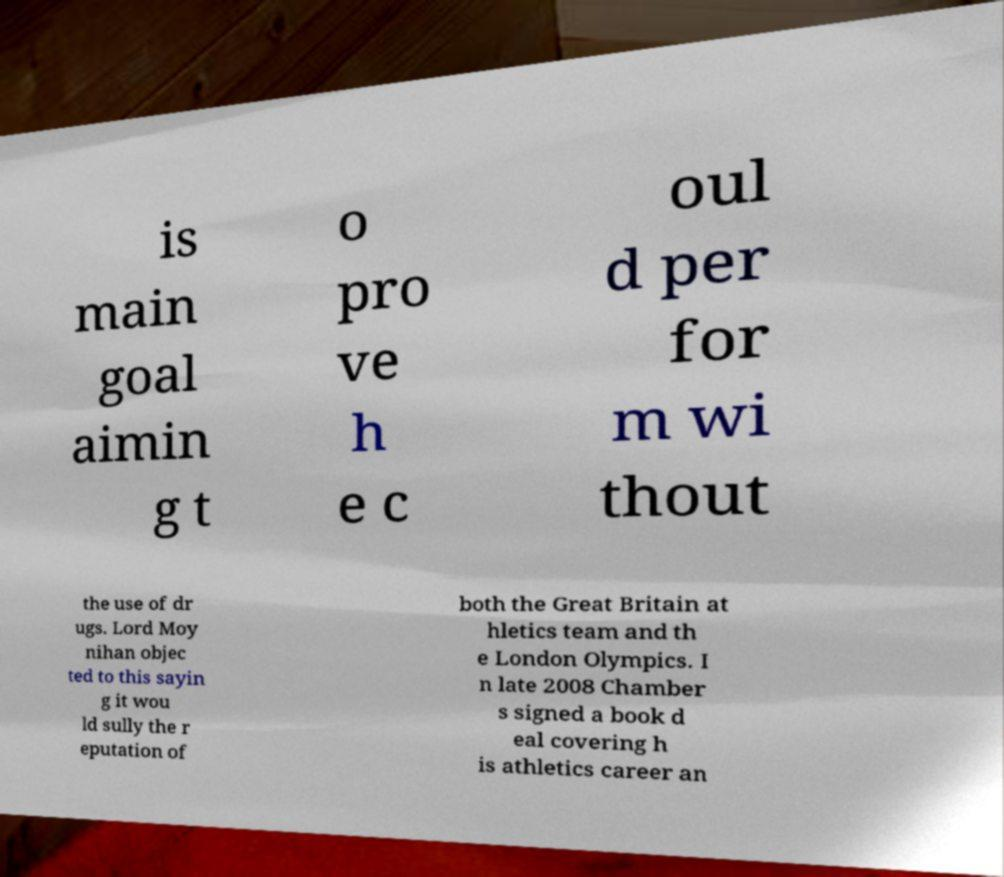For documentation purposes, I need the text within this image transcribed. Could you provide that? is main goal aimin g t o pro ve h e c oul d per for m wi thout the use of dr ugs. Lord Moy nihan objec ted to this sayin g it wou ld sully the r eputation of both the Great Britain at hletics team and th e London Olympics. I n late 2008 Chamber s signed a book d eal covering h is athletics career an 